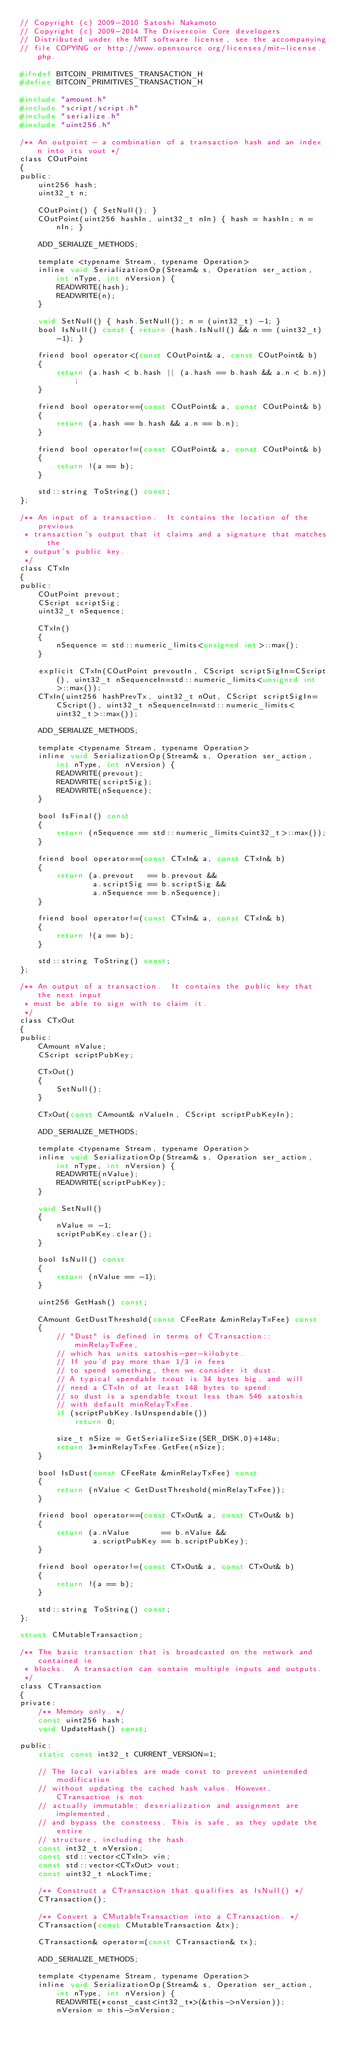<code> <loc_0><loc_0><loc_500><loc_500><_C_>// Copyright (c) 2009-2010 Satoshi Nakamoto
// Copyright (c) 2009-2014 The Drivercoin Core developers
// Distributed under the MIT software license, see the accompanying
// file COPYING or http://www.opensource.org/licenses/mit-license.php.

#ifndef BITCOIN_PRIMITIVES_TRANSACTION_H
#define BITCOIN_PRIMITIVES_TRANSACTION_H

#include "amount.h"
#include "script/script.h"
#include "serialize.h"
#include "uint256.h"

/** An outpoint - a combination of a transaction hash and an index n into its vout */
class COutPoint
{
public:
    uint256 hash;
    uint32_t n;

    COutPoint() { SetNull(); }
    COutPoint(uint256 hashIn, uint32_t nIn) { hash = hashIn; n = nIn; }

    ADD_SERIALIZE_METHODS;

    template <typename Stream, typename Operation>
    inline void SerializationOp(Stream& s, Operation ser_action, int nType, int nVersion) {
        READWRITE(hash);
        READWRITE(n);
    }

    void SetNull() { hash.SetNull(); n = (uint32_t) -1; }
    bool IsNull() const { return (hash.IsNull() && n == (uint32_t) -1); }

    friend bool operator<(const COutPoint& a, const COutPoint& b)
    {
        return (a.hash < b.hash || (a.hash == b.hash && a.n < b.n));
    }

    friend bool operator==(const COutPoint& a, const COutPoint& b)
    {
        return (a.hash == b.hash && a.n == b.n);
    }

    friend bool operator!=(const COutPoint& a, const COutPoint& b)
    {
        return !(a == b);
    }

    std::string ToString() const;
};

/** An input of a transaction.  It contains the location of the previous
 * transaction's output that it claims and a signature that matches the
 * output's public key.
 */
class CTxIn
{
public:
    COutPoint prevout;
    CScript scriptSig;
    uint32_t nSequence;

    CTxIn()
    {
        nSequence = std::numeric_limits<unsigned int>::max();
    }

    explicit CTxIn(COutPoint prevoutIn, CScript scriptSigIn=CScript(), uint32_t nSequenceIn=std::numeric_limits<unsigned int>::max());
    CTxIn(uint256 hashPrevTx, uint32_t nOut, CScript scriptSigIn=CScript(), uint32_t nSequenceIn=std::numeric_limits<uint32_t>::max());

    ADD_SERIALIZE_METHODS;

    template <typename Stream, typename Operation>
    inline void SerializationOp(Stream& s, Operation ser_action, int nType, int nVersion) {
        READWRITE(prevout);
        READWRITE(scriptSig);
        READWRITE(nSequence);
    }

    bool IsFinal() const
    {
        return (nSequence == std::numeric_limits<uint32_t>::max());
    }

    friend bool operator==(const CTxIn& a, const CTxIn& b)
    {
        return (a.prevout   == b.prevout &&
                a.scriptSig == b.scriptSig &&
                a.nSequence == b.nSequence);
    }

    friend bool operator!=(const CTxIn& a, const CTxIn& b)
    {
        return !(a == b);
    }

    std::string ToString() const;
};

/** An output of a transaction.  It contains the public key that the next input
 * must be able to sign with to claim it.
 */
class CTxOut
{
public:
    CAmount nValue;
    CScript scriptPubKey;

    CTxOut()
    {
        SetNull();
    }

    CTxOut(const CAmount& nValueIn, CScript scriptPubKeyIn);

    ADD_SERIALIZE_METHODS;

    template <typename Stream, typename Operation>
    inline void SerializationOp(Stream& s, Operation ser_action, int nType, int nVersion) {
        READWRITE(nValue);
        READWRITE(scriptPubKey);
    }

    void SetNull()
    {
        nValue = -1;
        scriptPubKey.clear();
    }

    bool IsNull() const
    {
        return (nValue == -1);
    }

    uint256 GetHash() const;

    CAmount GetDustThreshold(const CFeeRate &minRelayTxFee) const
    {
        // "Dust" is defined in terms of CTransaction::minRelayTxFee,
        // which has units satoshis-per-kilobyte.
        // If you'd pay more than 1/3 in fees
        // to spend something, then we consider it dust.
        // A typical spendable txout is 34 bytes big, and will
        // need a CTxIn of at least 148 bytes to spend:
        // so dust is a spendable txout less than 546 satoshis
        // with default minRelayTxFee.
        if (scriptPubKey.IsUnspendable())
            return 0;

        size_t nSize = GetSerializeSize(SER_DISK,0)+148u;
        return 3*minRelayTxFee.GetFee(nSize);
    }

    bool IsDust(const CFeeRate &minRelayTxFee) const
    {
        return (nValue < GetDustThreshold(minRelayTxFee));
    }

    friend bool operator==(const CTxOut& a, const CTxOut& b)
    {
        return (a.nValue       == b.nValue &&
                a.scriptPubKey == b.scriptPubKey);
    }

    friend bool operator!=(const CTxOut& a, const CTxOut& b)
    {
        return !(a == b);
    }

    std::string ToString() const;
};

struct CMutableTransaction;

/** The basic transaction that is broadcasted on the network and contained in
 * blocks.  A transaction can contain multiple inputs and outputs.
 */
class CTransaction
{
private:
    /** Memory only. */
    const uint256 hash;
    void UpdateHash() const;

public:
    static const int32_t CURRENT_VERSION=1;

    // The local variables are made const to prevent unintended modification
    // without updating the cached hash value. However, CTransaction is not
    // actually immutable; deserialization and assignment are implemented,
    // and bypass the constness. This is safe, as they update the entire
    // structure, including the hash.
    const int32_t nVersion;
    const std::vector<CTxIn> vin;
    const std::vector<CTxOut> vout;
    const uint32_t nLockTime;

    /** Construct a CTransaction that qualifies as IsNull() */
    CTransaction();

    /** Convert a CMutableTransaction into a CTransaction. */
    CTransaction(const CMutableTransaction &tx);

    CTransaction& operator=(const CTransaction& tx);

    ADD_SERIALIZE_METHODS;

    template <typename Stream, typename Operation>
    inline void SerializationOp(Stream& s, Operation ser_action, int nType, int nVersion) {
        READWRITE(*const_cast<int32_t*>(&this->nVersion));
        nVersion = this->nVersion;</code> 